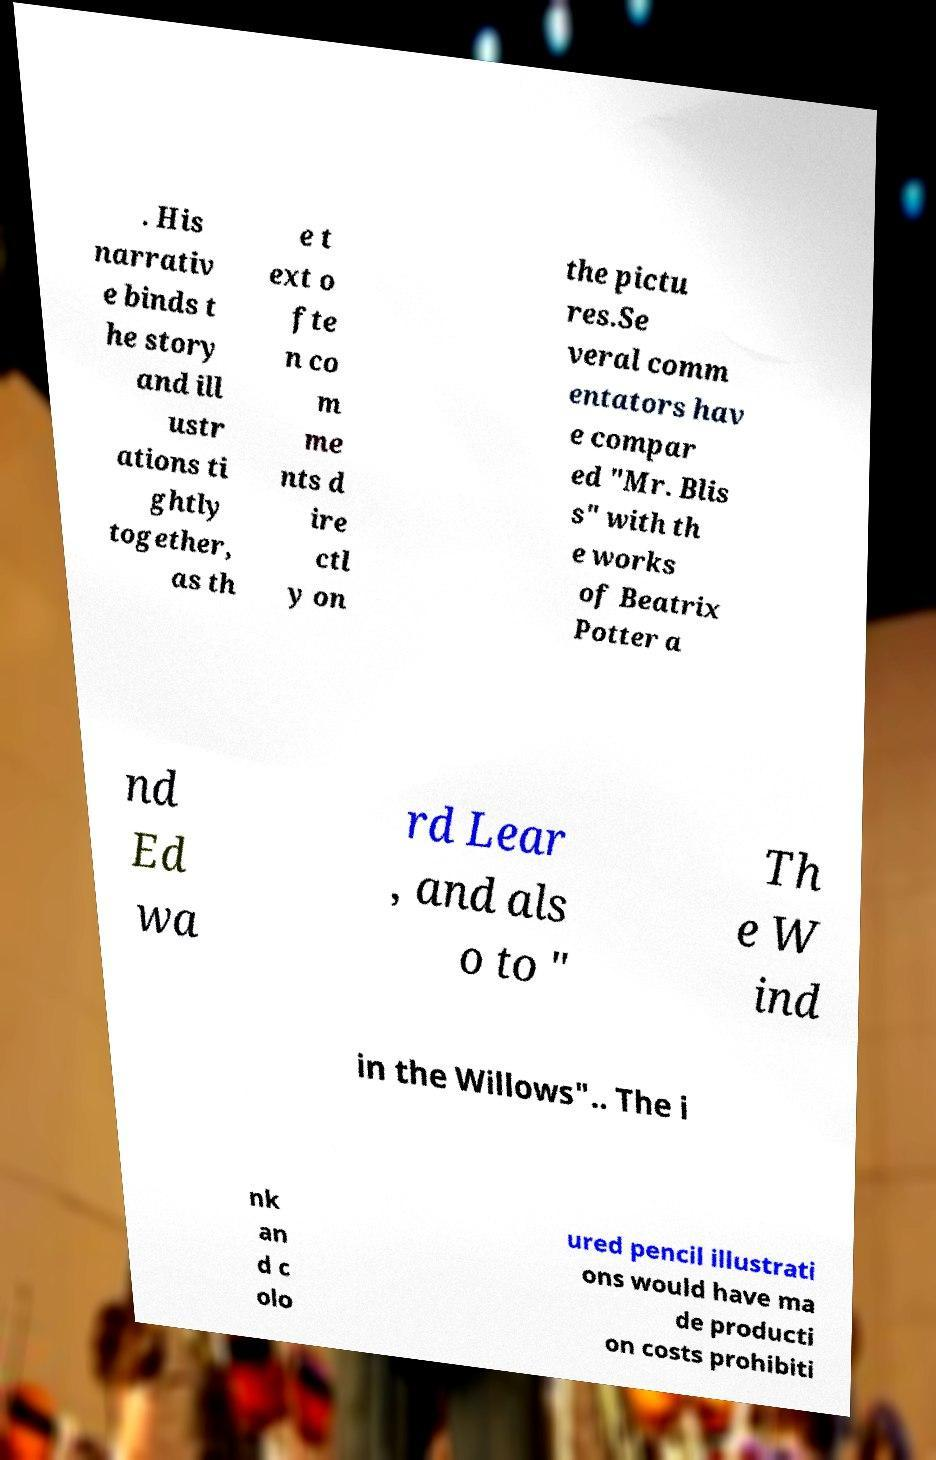Please read and relay the text visible in this image. What does it say? . His narrativ e binds t he story and ill ustr ations ti ghtly together, as th e t ext o fte n co m me nts d ire ctl y on the pictu res.Se veral comm entators hav e compar ed "Mr. Blis s" with th e works of Beatrix Potter a nd Ed wa rd Lear , and als o to " Th e W ind in the Willows".. The i nk an d c olo ured pencil illustrati ons would have ma de producti on costs prohibiti 